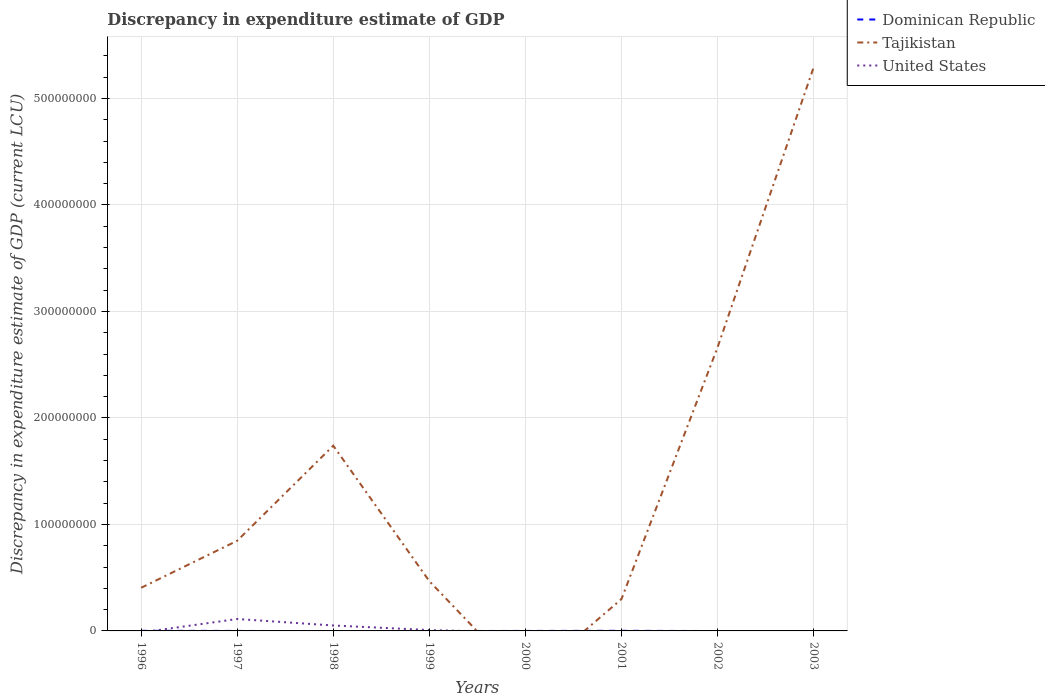How many different coloured lines are there?
Offer a very short reply. 3. Across all years, what is the maximum discrepancy in expenditure estimate of GDP in United States?
Provide a succinct answer. 0. What is the total discrepancy in expenditure estimate of GDP in Tajikistan in the graph?
Make the answer very short. 3.79e+07. What is the difference between the highest and the second highest discrepancy in expenditure estimate of GDP in Tajikistan?
Your answer should be compact. 5.29e+08. What is the difference between the highest and the lowest discrepancy in expenditure estimate of GDP in Dominican Republic?
Ensure brevity in your answer.  2. Is the discrepancy in expenditure estimate of GDP in Dominican Republic strictly greater than the discrepancy in expenditure estimate of GDP in United States over the years?
Make the answer very short. No. Are the values on the major ticks of Y-axis written in scientific E-notation?
Your answer should be compact. No. Does the graph contain grids?
Provide a short and direct response. Yes. Where does the legend appear in the graph?
Your response must be concise. Top right. What is the title of the graph?
Offer a very short reply. Discrepancy in expenditure estimate of GDP. What is the label or title of the Y-axis?
Your answer should be compact. Discrepancy in expenditure estimate of GDP (current LCU). What is the Discrepancy in expenditure estimate of GDP (current LCU) of Dominican Republic in 1996?
Give a very brief answer. 1.00e+05. What is the Discrepancy in expenditure estimate of GDP (current LCU) in Tajikistan in 1996?
Offer a terse response. 4.05e+07. What is the Discrepancy in expenditure estimate of GDP (current LCU) in Dominican Republic in 1997?
Make the answer very short. 2.2e-5. What is the Discrepancy in expenditure estimate of GDP (current LCU) of Tajikistan in 1997?
Give a very brief answer. 8.47e+07. What is the Discrepancy in expenditure estimate of GDP (current LCU) of United States in 1997?
Offer a very short reply. 1.12e+07. What is the Discrepancy in expenditure estimate of GDP (current LCU) of Dominican Republic in 1998?
Your answer should be very brief. 0. What is the Discrepancy in expenditure estimate of GDP (current LCU) of Tajikistan in 1998?
Keep it short and to the point. 1.74e+08. What is the Discrepancy in expenditure estimate of GDP (current LCU) in United States in 1998?
Your answer should be compact. 5.10e+06. What is the Discrepancy in expenditure estimate of GDP (current LCU) in Dominican Republic in 1999?
Ensure brevity in your answer.  0. What is the Discrepancy in expenditure estimate of GDP (current LCU) in Tajikistan in 1999?
Provide a short and direct response. 4.67e+07. What is the Discrepancy in expenditure estimate of GDP (current LCU) in United States in 1999?
Give a very brief answer. 8.00e+05. What is the Discrepancy in expenditure estimate of GDP (current LCU) in Dominican Republic in 2000?
Offer a very short reply. 3e-5. What is the Discrepancy in expenditure estimate of GDP (current LCU) in Tajikistan in 2000?
Make the answer very short. 0. What is the Discrepancy in expenditure estimate of GDP (current LCU) in United States in 2000?
Ensure brevity in your answer.  0. What is the Discrepancy in expenditure estimate of GDP (current LCU) of Dominican Republic in 2001?
Your answer should be very brief. 1.00e+05. What is the Discrepancy in expenditure estimate of GDP (current LCU) in Tajikistan in 2001?
Give a very brief answer. 2.99e+07. What is the Discrepancy in expenditure estimate of GDP (current LCU) in United States in 2001?
Make the answer very short. 0. What is the Discrepancy in expenditure estimate of GDP (current LCU) of Dominican Republic in 2002?
Keep it short and to the point. 0. What is the Discrepancy in expenditure estimate of GDP (current LCU) of Tajikistan in 2002?
Your response must be concise. 2.66e+08. What is the Discrepancy in expenditure estimate of GDP (current LCU) of United States in 2002?
Your answer should be compact. 0. What is the Discrepancy in expenditure estimate of GDP (current LCU) in Dominican Republic in 2003?
Keep it short and to the point. 0. What is the Discrepancy in expenditure estimate of GDP (current LCU) of Tajikistan in 2003?
Your answer should be very brief. 5.29e+08. Across all years, what is the maximum Discrepancy in expenditure estimate of GDP (current LCU) of Dominican Republic?
Provide a succinct answer. 1.00e+05. Across all years, what is the maximum Discrepancy in expenditure estimate of GDP (current LCU) in Tajikistan?
Your answer should be very brief. 5.29e+08. Across all years, what is the maximum Discrepancy in expenditure estimate of GDP (current LCU) in United States?
Your answer should be compact. 1.12e+07. Across all years, what is the minimum Discrepancy in expenditure estimate of GDP (current LCU) of Dominican Republic?
Offer a terse response. 0. Across all years, what is the minimum Discrepancy in expenditure estimate of GDP (current LCU) in Tajikistan?
Offer a very short reply. 0. Across all years, what is the minimum Discrepancy in expenditure estimate of GDP (current LCU) of United States?
Ensure brevity in your answer.  0. What is the total Discrepancy in expenditure estimate of GDP (current LCU) of Dominican Republic in the graph?
Offer a terse response. 2.00e+05. What is the total Discrepancy in expenditure estimate of GDP (current LCU) in Tajikistan in the graph?
Provide a short and direct response. 1.17e+09. What is the total Discrepancy in expenditure estimate of GDP (current LCU) of United States in the graph?
Offer a terse response. 1.71e+07. What is the difference between the Discrepancy in expenditure estimate of GDP (current LCU) in Tajikistan in 1996 and that in 1997?
Provide a succinct answer. -4.42e+07. What is the difference between the Discrepancy in expenditure estimate of GDP (current LCU) of Tajikistan in 1996 and that in 1998?
Ensure brevity in your answer.  -1.33e+08. What is the difference between the Discrepancy in expenditure estimate of GDP (current LCU) in Tajikistan in 1996 and that in 1999?
Your answer should be very brief. -6.24e+06. What is the difference between the Discrepancy in expenditure estimate of GDP (current LCU) in Dominican Republic in 1996 and that in 2001?
Your response must be concise. -0. What is the difference between the Discrepancy in expenditure estimate of GDP (current LCU) in Tajikistan in 1996 and that in 2001?
Provide a succinct answer. 1.06e+07. What is the difference between the Discrepancy in expenditure estimate of GDP (current LCU) of Tajikistan in 1996 and that in 2002?
Offer a very short reply. -2.26e+08. What is the difference between the Discrepancy in expenditure estimate of GDP (current LCU) of Tajikistan in 1996 and that in 2003?
Offer a terse response. -4.89e+08. What is the difference between the Discrepancy in expenditure estimate of GDP (current LCU) in Tajikistan in 1997 and that in 1998?
Offer a very short reply. -8.93e+07. What is the difference between the Discrepancy in expenditure estimate of GDP (current LCU) in United States in 1997 and that in 1998?
Your response must be concise. 6.10e+06. What is the difference between the Discrepancy in expenditure estimate of GDP (current LCU) in Tajikistan in 1997 and that in 1999?
Offer a very short reply. 3.79e+07. What is the difference between the Discrepancy in expenditure estimate of GDP (current LCU) of United States in 1997 and that in 1999?
Offer a terse response. 1.04e+07. What is the difference between the Discrepancy in expenditure estimate of GDP (current LCU) of Dominican Republic in 1997 and that in 2000?
Ensure brevity in your answer.  -0. What is the difference between the Discrepancy in expenditure estimate of GDP (current LCU) in Dominican Republic in 1997 and that in 2001?
Offer a very short reply. -1.00e+05. What is the difference between the Discrepancy in expenditure estimate of GDP (current LCU) in Tajikistan in 1997 and that in 2001?
Offer a very short reply. 5.47e+07. What is the difference between the Discrepancy in expenditure estimate of GDP (current LCU) in Tajikistan in 1997 and that in 2002?
Make the answer very short. -1.82e+08. What is the difference between the Discrepancy in expenditure estimate of GDP (current LCU) of Tajikistan in 1997 and that in 2003?
Offer a terse response. -4.45e+08. What is the difference between the Discrepancy in expenditure estimate of GDP (current LCU) of Tajikistan in 1998 and that in 1999?
Your answer should be compact. 1.27e+08. What is the difference between the Discrepancy in expenditure estimate of GDP (current LCU) in United States in 1998 and that in 1999?
Ensure brevity in your answer.  4.30e+06. What is the difference between the Discrepancy in expenditure estimate of GDP (current LCU) in Tajikistan in 1998 and that in 2001?
Keep it short and to the point. 1.44e+08. What is the difference between the Discrepancy in expenditure estimate of GDP (current LCU) of Tajikistan in 1998 and that in 2002?
Give a very brief answer. -9.23e+07. What is the difference between the Discrepancy in expenditure estimate of GDP (current LCU) in Tajikistan in 1998 and that in 2003?
Keep it short and to the point. -3.55e+08. What is the difference between the Discrepancy in expenditure estimate of GDP (current LCU) of Tajikistan in 1999 and that in 2001?
Give a very brief answer. 1.68e+07. What is the difference between the Discrepancy in expenditure estimate of GDP (current LCU) in Tajikistan in 1999 and that in 2002?
Offer a very short reply. -2.20e+08. What is the difference between the Discrepancy in expenditure estimate of GDP (current LCU) in Tajikistan in 1999 and that in 2003?
Give a very brief answer. -4.83e+08. What is the difference between the Discrepancy in expenditure estimate of GDP (current LCU) of Dominican Republic in 2000 and that in 2001?
Provide a succinct answer. -1.00e+05. What is the difference between the Discrepancy in expenditure estimate of GDP (current LCU) of Tajikistan in 2001 and that in 2002?
Your response must be concise. -2.36e+08. What is the difference between the Discrepancy in expenditure estimate of GDP (current LCU) of Tajikistan in 2001 and that in 2003?
Keep it short and to the point. -4.99e+08. What is the difference between the Discrepancy in expenditure estimate of GDP (current LCU) in Tajikistan in 2002 and that in 2003?
Offer a very short reply. -2.63e+08. What is the difference between the Discrepancy in expenditure estimate of GDP (current LCU) in Dominican Republic in 1996 and the Discrepancy in expenditure estimate of GDP (current LCU) in Tajikistan in 1997?
Offer a very short reply. -8.46e+07. What is the difference between the Discrepancy in expenditure estimate of GDP (current LCU) of Dominican Republic in 1996 and the Discrepancy in expenditure estimate of GDP (current LCU) of United States in 1997?
Keep it short and to the point. -1.11e+07. What is the difference between the Discrepancy in expenditure estimate of GDP (current LCU) of Tajikistan in 1996 and the Discrepancy in expenditure estimate of GDP (current LCU) of United States in 1997?
Keep it short and to the point. 2.93e+07. What is the difference between the Discrepancy in expenditure estimate of GDP (current LCU) of Dominican Republic in 1996 and the Discrepancy in expenditure estimate of GDP (current LCU) of Tajikistan in 1998?
Provide a short and direct response. -1.74e+08. What is the difference between the Discrepancy in expenditure estimate of GDP (current LCU) of Dominican Republic in 1996 and the Discrepancy in expenditure estimate of GDP (current LCU) of United States in 1998?
Make the answer very short. -5.00e+06. What is the difference between the Discrepancy in expenditure estimate of GDP (current LCU) of Tajikistan in 1996 and the Discrepancy in expenditure estimate of GDP (current LCU) of United States in 1998?
Your answer should be compact. 3.54e+07. What is the difference between the Discrepancy in expenditure estimate of GDP (current LCU) in Dominican Republic in 1996 and the Discrepancy in expenditure estimate of GDP (current LCU) in Tajikistan in 1999?
Provide a short and direct response. -4.66e+07. What is the difference between the Discrepancy in expenditure estimate of GDP (current LCU) of Dominican Republic in 1996 and the Discrepancy in expenditure estimate of GDP (current LCU) of United States in 1999?
Provide a short and direct response. -7.00e+05. What is the difference between the Discrepancy in expenditure estimate of GDP (current LCU) of Tajikistan in 1996 and the Discrepancy in expenditure estimate of GDP (current LCU) of United States in 1999?
Offer a terse response. 3.97e+07. What is the difference between the Discrepancy in expenditure estimate of GDP (current LCU) of Dominican Republic in 1996 and the Discrepancy in expenditure estimate of GDP (current LCU) of Tajikistan in 2001?
Your response must be concise. -2.98e+07. What is the difference between the Discrepancy in expenditure estimate of GDP (current LCU) in Dominican Republic in 1996 and the Discrepancy in expenditure estimate of GDP (current LCU) in Tajikistan in 2002?
Offer a terse response. -2.66e+08. What is the difference between the Discrepancy in expenditure estimate of GDP (current LCU) of Dominican Republic in 1996 and the Discrepancy in expenditure estimate of GDP (current LCU) of Tajikistan in 2003?
Offer a terse response. -5.29e+08. What is the difference between the Discrepancy in expenditure estimate of GDP (current LCU) of Dominican Republic in 1997 and the Discrepancy in expenditure estimate of GDP (current LCU) of Tajikistan in 1998?
Provide a short and direct response. -1.74e+08. What is the difference between the Discrepancy in expenditure estimate of GDP (current LCU) of Dominican Republic in 1997 and the Discrepancy in expenditure estimate of GDP (current LCU) of United States in 1998?
Your answer should be very brief. -5.10e+06. What is the difference between the Discrepancy in expenditure estimate of GDP (current LCU) in Tajikistan in 1997 and the Discrepancy in expenditure estimate of GDP (current LCU) in United States in 1998?
Your response must be concise. 7.96e+07. What is the difference between the Discrepancy in expenditure estimate of GDP (current LCU) of Dominican Republic in 1997 and the Discrepancy in expenditure estimate of GDP (current LCU) of Tajikistan in 1999?
Offer a terse response. -4.67e+07. What is the difference between the Discrepancy in expenditure estimate of GDP (current LCU) of Dominican Republic in 1997 and the Discrepancy in expenditure estimate of GDP (current LCU) of United States in 1999?
Provide a succinct answer. -8.00e+05. What is the difference between the Discrepancy in expenditure estimate of GDP (current LCU) of Tajikistan in 1997 and the Discrepancy in expenditure estimate of GDP (current LCU) of United States in 1999?
Provide a short and direct response. 8.39e+07. What is the difference between the Discrepancy in expenditure estimate of GDP (current LCU) in Dominican Republic in 1997 and the Discrepancy in expenditure estimate of GDP (current LCU) in Tajikistan in 2001?
Make the answer very short. -2.99e+07. What is the difference between the Discrepancy in expenditure estimate of GDP (current LCU) in Dominican Republic in 1997 and the Discrepancy in expenditure estimate of GDP (current LCU) in Tajikistan in 2002?
Your answer should be very brief. -2.66e+08. What is the difference between the Discrepancy in expenditure estimate of GDP (current LCU) in Dominican Republic in 1997 and the Discrepancy in expenditure estimate of GDP (current LCU) in Tajikistan in 2003?
Offer a very short reply. -5.29e+08. What is the difference between the Discrepancy in expenditure estimate of GDP (current LCU) of Tajikistan in 1998 and the Discrepancy in expenditure estimate of GDP (current LCU) of United States in 1999?
Your answer should be compact. 1.73e+08. What is the difference between the Discrepancy in expenditure estimate of GDP (current LCU) of Dominican Republic in 2000 and the Discrepancy in expenditure estimate of GDP (current LCU) of Tajikistan in 2001?
Provide a succinct answer. -2.99e+07. What is the difference between the Discrepancy in expenditure estimate of GDP (current LCU) in Dominican Republic in 2000 and the Discrepancy in expenditure estimate of GDP (current LCU) in Tajikistan in 2002?
Offer a very short reply. -2.66e+08. What is the difference between the Discrepancy in expenditure estimate of GDP (current LCU) of Dominican Republic in 2000 and the Discrepancy in expenditure estimate of GDP (current LCU) of Tajikistan in 2003?
Ensure brevity in your answer.  -5.29e+08. What is the difference between the Discrepancy in expenditure estimate of GDP (current LCU) in Dominican Republic in 2001 and the Discrepancy in expenditure estimate of GDP (current LCU) in Tajikistan in 2002?
Offer a very short reply. -2.66e+08. What is the difference between the Discrepancy in expenditure estimate of GDP (current LCU) of Dominican Republic in 2001 and the Discrepancy in expenditure estimate of GDP (current LCU) of Tajikistan in 2003?
Offer a terse response. -5.29e+08. What is the average Discrepancy in expenditure estimate of GDP (current LCU) in Dominican Republic per year?
Provide a succinct answer. 2.50e+04. What is the average Discrepancy in expenditure estimate of GDP (current LCU) of Tajikistan per year?
Provide a short and direct response. 1.46e+08. What is the average Discrepancy in expenditure estimate of GDP (current LCU) of United States per year?
Keep it short and to the point. 2.14e+06. In the year 1996, what is the difference between the Discrepancy in expenditure estimate of GDP (current LCU) of Dominican Republic and Discrepancy in expenditure estimate of GDP (current LCU) of Tajikistan?
Provide a succinct answer. -4.04e+07. In the year 1997, what is the difference between the Discrepancy in expenditure estimate of GDP (current LCU) of Dominican Republic and Discrepancy in expenditure estimate of GDP (current LCU) of Tajikistan?
Offer a very short reply. -8.47e+07. In the year 1997, what is the difference between the Discrepancy in expenditure estimate of GDP (current LCU) of Dominican Republic and Discrepancy in expenditure estimate of GDP (current LCU) of United States?
Provide a short and direct response. -1.12e+07. In the year 1997, what is the difference between the Discrepancy in expenditure estimate of GDP (current LCU) in Tajikistan and Discrepancy in expenditure estimate of GDP (current LCU) in United States?
Provide a short and direct response. 7.35e+07. In the year 1998, what is the difference between the Discrepancy in expenditure estimate of GDP (current LCU) of Tajikistan and Discrepancy in expenditure estimate of GDP (current LCU) of United States?
Make the answer very short. 1.69e+08. In the year 1999, what is the difference between the Discrepancy in expenditure estimate of GDP (current LCU) of Tajikistan and Discrepancy in expenditure estimate of GDP (current LCU) of United States?
Offer a terse response. 4.59e+07. In the year 2001, what is the difference between the Discrepancy in expenditure estimate of GDP (current LCU) of Dominican Republic and Discrepancy in expenditure estimate of GDP (current LCU) of Tajikistan?
Give a very brief answer. -2.98e+07. What is the ratio of the Discrepancy in expenditure estimate of GDP (current LCU) in Dominican Republic in 1996 to that in 1997?
Your answer should be very brief. 4.55e+09. What is the ratio of the Discrepancy in expenditure estimate of GDP (current LCU) in Tajikistan in 1996 to that in 1997?
Your answer should be very brief. 0.48. What is the ratio of the Discrepancy in expenditure estimate of GDP (current LCU) of Tajikistan in 1996 to that in 1998?
Provide a short and direct response. 0.23. What is the ratio of the Discrepancy in expenditure estimate of GDP (current LCU) in Tajikistan in 1996 to that in 1999?
Provide a succinct answer. 0.87. What is the ratio of the Discrepancy in expenditure estimate of GDP (current LCU) of Dominican Republic in 1996 to that in 2000?
Ensure brevity in your answer.  3.33e+09. What is the ratio of the Discrepancy in expenditure estimate of GDP (current LCU) of Tajikistan in 1996 to that in 2001?
Offer a very short reply. 1.35. What is the ratio of the Discrepancy in expenditure estimate of GDP (current LCU) of Tajikistan in 1996 to that in 2002?
Provide a succinct answer. 0.15. What is the ratio of the Discrepancy in expenditure estimate of GDP (current LCU) of Tajikistan in 1996 to that in 2003?
Make the answer very short. 0.08. What is the ratio of the Discrepancy in expenditure estimate of GDP (current LCU) of Tajikistan in 1997 to that in 1998?
Give a very brief answer. 0.49. What is the ratio of the Discrepancy in expenditure estimate of GDP (current LCU) in United States in 1997 to that in 1998?
Offer a very short reply. 2.2. What is the ratio of the Discrepancy in expenditure estimate of GDP (current LCU) in Tajikistan in 1997 to that in 1999?
Offer a terse response. 1.81. What is the ratio of the Discrepancy in expenditure estimate of GDP (current LCU) of United States in 1997 to that in 1999?
Ensure brevity in your answer.  14. What is the ratio of the Discrepancy in expenditure estimate of GDP (current LCU) of Dominican Republic in 1997 to that in 2000?
Ensure brevity in your answer.  0.73. What is the ratio of the Discrepancy in expenditure estimate of GDP (current LCU) in Tajikistan in 1997 to that in 2001?
Give a very brief answer. 2.83. What is the ratio of the Discrepancy in expenditure estimate of GDP (current LCU) in Tajikistan in 1997 to that in 2002?
Give a very brief answer. 0.32. What is the ratio of the Discrepancy in expenditure estimate of GDP (current LCU) in Tajikistan in 1997 to that in 2003?
Provide a short and direct response. 0.16. What is the ratio of the Discrepancy in expenditure estimate of GDP (current LCU) of Tajikistan in 1998 to that in 1999?
Offer a very short reply. 3.72. What is the ratio of the Discrepancy in expenditure estimate of GDP (current LCU) of United States in 1998 to that in 1999?
Offer a terse response. 6.38. What is the ratio of the Discrepancy in expenditure estimate of GDP (current LCU) in Tajikistan in 1998 to that in 2001?
Offer a terse response. 5.81. What is the ratio of the Discrepancy in expenditure estimate of GDP (current LCU) of Tajikistan in 1998 to that in 2002?
Your answer should be compact. 0.65. What is the ratio of the Discrepancy in expenditure estimate of GDP (current LCU) in Tajikistan in 1998 to that in 2003?
Ensure brevity in your answer.  0.33. What is the ratio of the Discrepancy in expenditure estimate of GDP (current LCU) of Tajikistan in 1999 to that in 2001?
Offer a very short reply. 1.56. What is the ratio of the Discrepancy in expenditure estimate of GDP (current LCU) in Tajikistan in 1999 to that in 2002?
Offer a very short reply. 0.18. What is the ratio of the Discrepancy in expenditure estimate of GDP (current LCU) in Tajikistan in 1999 to that in 2003?
Offer a terse response. 0.09. What is the ratio of the Discrepancy in expenditure estimate of GDP (current LCU) in Dominican Republic in 2000 to that in 2001?
Provide a succinct answer. 0. What is the ratio of the Discrepancy in expenditure estimate of GDP (current LCU) in Tajikistan in 2001 to that in 2002?
Keep it short and to the point. 0.11. What is the ratio of the Discrepancy in expenditure estimate of GDP (current LCU) in Tajikistan in 2001 to that in 2003?
Offer a very short reply. 0.06. What is the ratio of the Discrepancy in expenditure estimate of GDP (current LCU) in Tajikistan in 2002 to that in 2003?
Offer a very short reply. 0.5. What is the difference between the highest and the second highest Discrepancy in expenditure estimate of GDP (current LCU) of Dominican Republic?
Make the answer very short. 0. What is the difference between the highest and the second highest Discrepancy in expenditure estimate of GDP (current LCU) in Tajikistan?
Your answer should be very brief. 2.63e+08. What is the difference between the highest and the second highest Discrepancy in expenditure estimate of GDP (current LCU) of United States?
Ensure brevity in your answer.  6.10e+06. What is the difference between the highest and the lowest Discrepancy in expenditure estimate of GDP (current LCU) in Tajikistan?
Give a very brief answer. 5.29e+08. What is the difference between the highest and the lowest Discrepancy in expenditure estimate of GDP (current LCU) in United States?
Make the answer very short. 1.12e+07. 